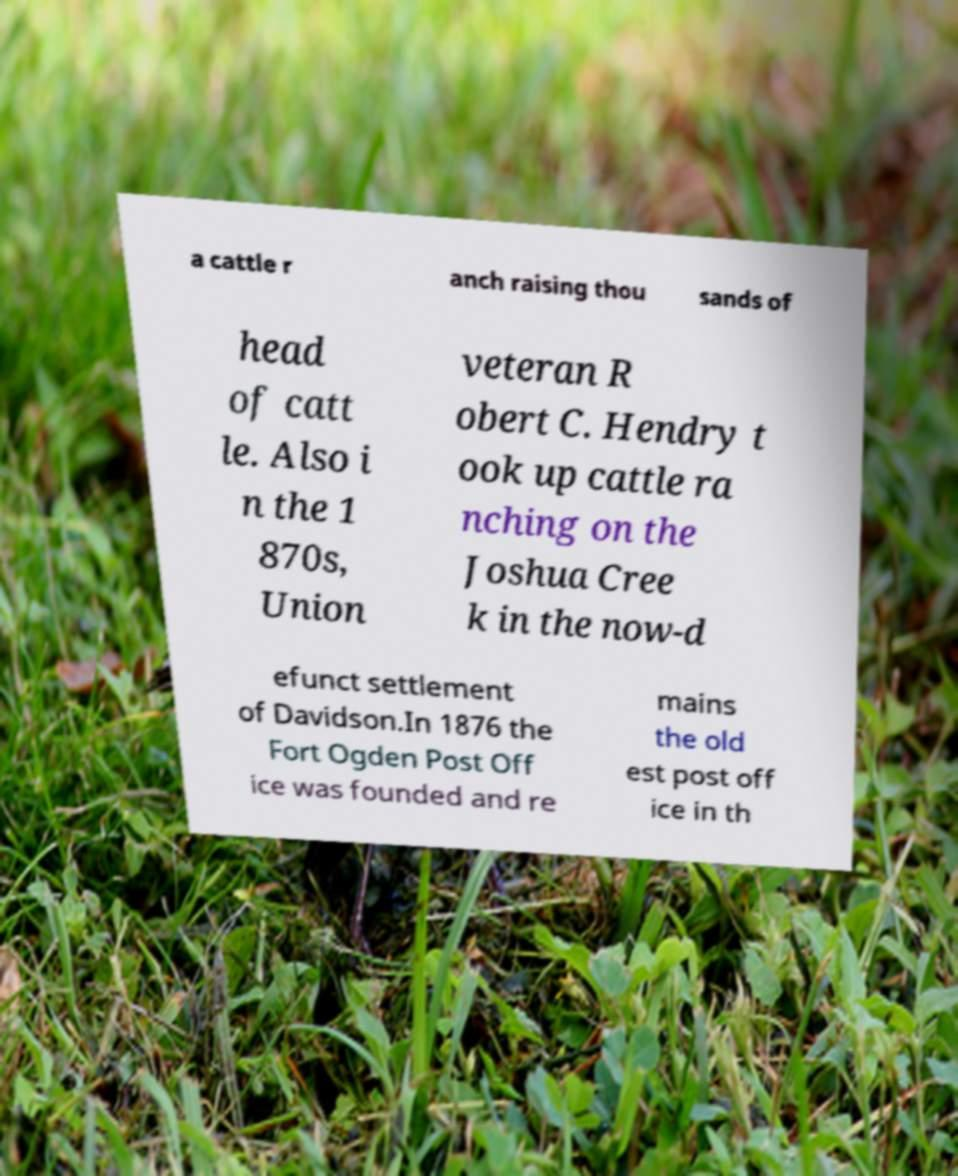Please read and relay the text visible in this image. What does it say? a cattle r anch raising thou sands of head of catt le. Also i n the 1 870s, Union veteran R obert C. Hendry t ook up cattle ra nching on the Joshua Cree k in the now-d efunct settlement of Davidson.In 1876 the Fort Ogden Post Off ice was founded and re mains the old est post off ice in th 